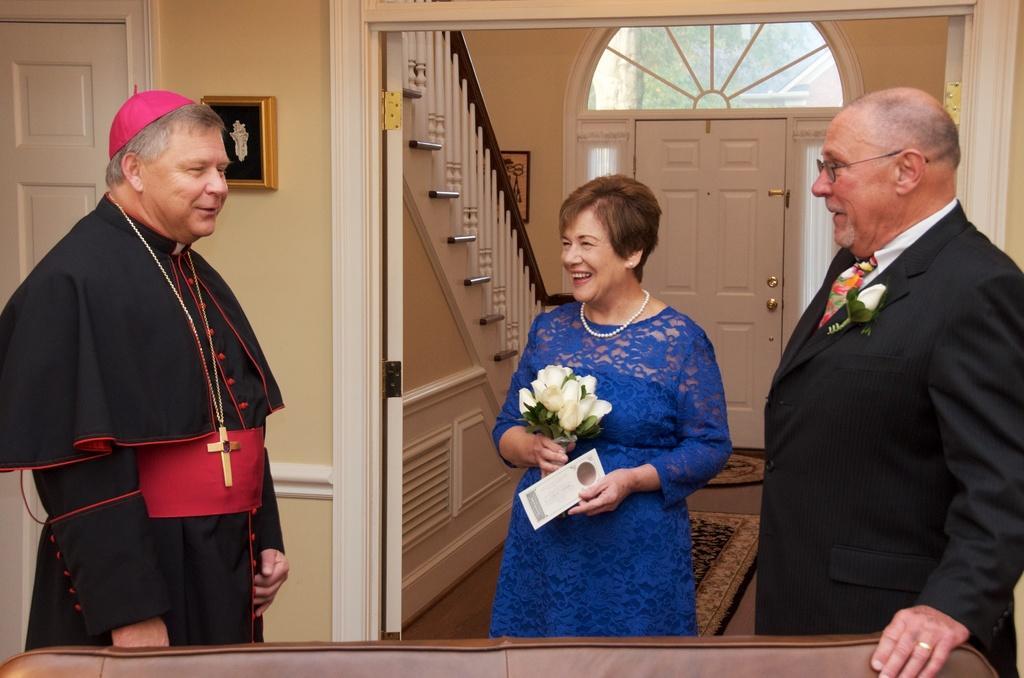Can you describe this image briefly? In this image we can see people standing. In the background of the image there is a door. There is a staircase. There is a carpet. To the left side of the image there is a photo frame on the wall. 